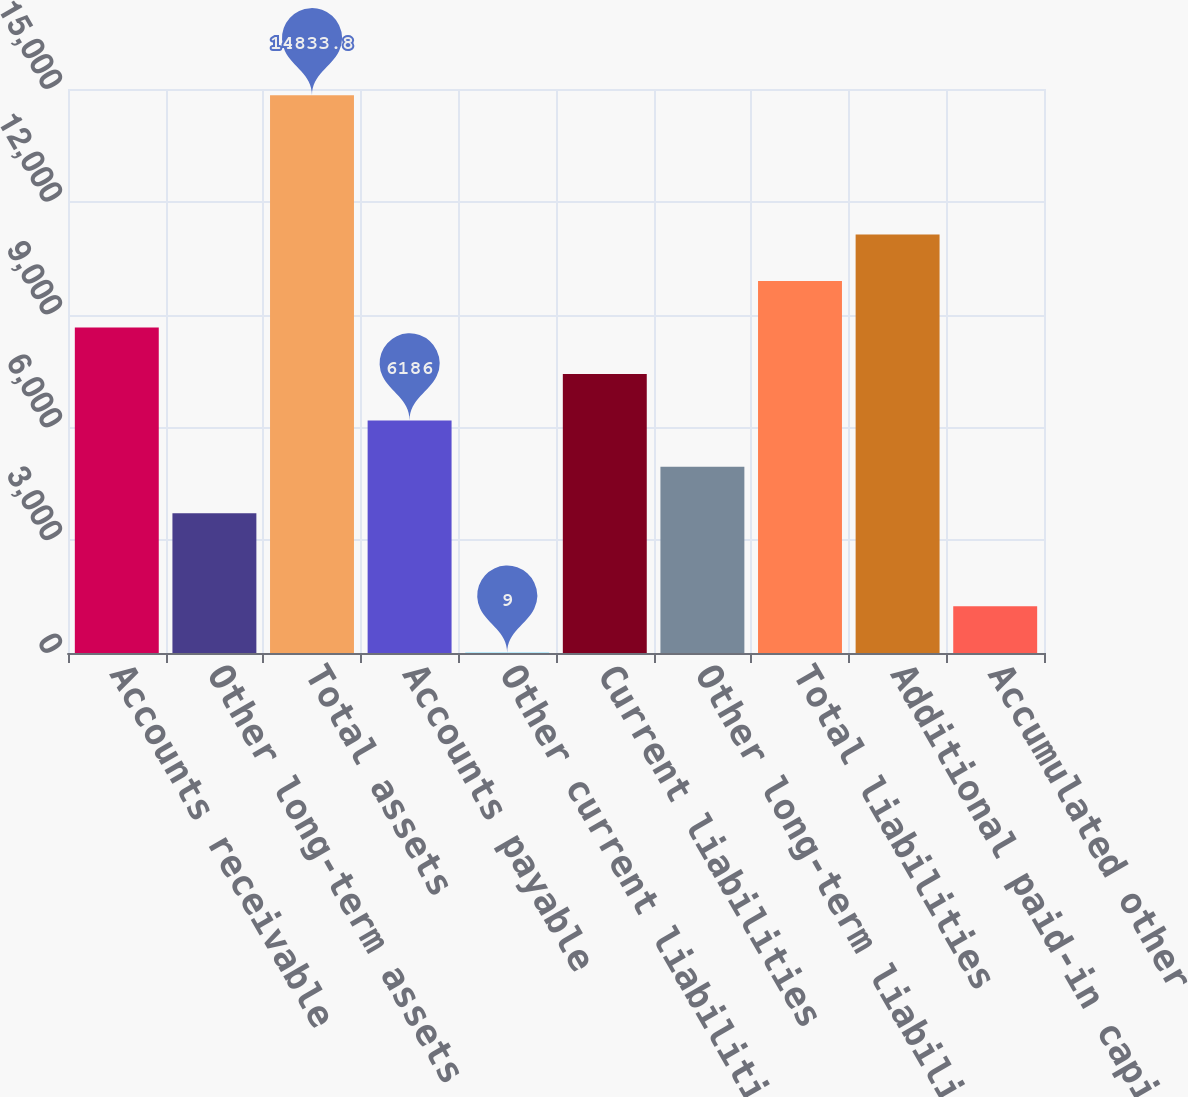Convert chart to OTSL. <chart><loc_0><loc_0><loc_500><loc_500><bar_chart><fcel>Accounts receivable<fcel>Other long-term assets<fcel>Total assets<fcel>Accounts payable<fcel>Other current liabilities<fcel>Current liabilities<fcel>Other long-term liabilities<fcel>Total liabilities<fcel>Additional paid-in capital<fcel>Accumulated other<nl><fcel>8656.8<fcel>3715.2<fcel>14833.8<fcel>6186<fcel>9<fcel>7421.4<fcel>4950.6<fcel>9892.2<fcel>11127.6<fcel>1244.4<nl></chart> 